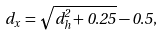<formula> <loc_0><loc_0><loc_500><loc_500>d _ { x } \, = \sqrt { d _ { h } ^ { 2 } + 0 . 2 5 } - 0 . 5 ,</formula> 